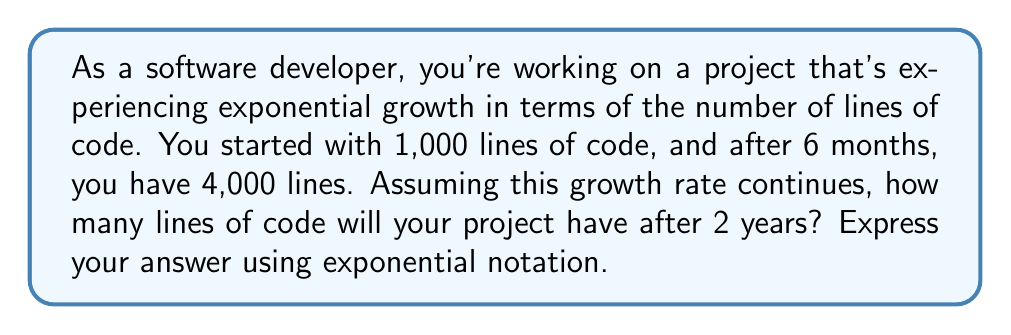Teach me how to tackle this problem. Let's approach this step-by-step:

1) We can model this growth using the exponential function:

   $A = P(1 + r)^t$

   Where:
   $A$ = final amount
   $P$ = initial amount
   $r$ = growth rate (per unit time)
   $t$ = time

2) We know:
   $P = 1,000$ (initial lines of code)
   $t = 6$ months (or 0.5 years)
   $A = 4,000$ (lines of code after 6 months)

3) Let's plug these into our equation:

   $4,000 = 1,000(1 + r)^{0.5}$

4) Divide both sides by 1,000:

   $4 = (1 + r)^{0.5}$

5) Square both sides:

   $16 = (1 + r)$

6) Subtract 1 from both sides:

   $15 = r$

7) So the growth rate is 1500% per year.

8) Now, let's use this to calculate the lines of code after 2 years:

   $A = 1,000(1 + 15)^2$
   $A = 1,000(16)^2$
   $A = 1,000 * 256$
   $A = 256,000$

Therefore, after 2 years, the project will have 256,000 lines of code.

9) To express this in exponential notation:

   $256,000 = 2.56 * 10^5$
Answer: $2.56 * 10^5$ lines of code 